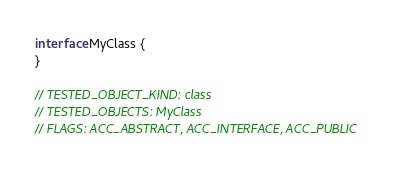Convert code to text. <code><loc_0><loc_0><loc_500><loc_500><_Kotlin_>interface MyClass {
}

// TESTED_OBJECT_KIND: class
// TESTED_OBJECTS: MyClass
// FLAGS: ACC_ABSTRACT, ACC_INTERFACE, ACC_PUBLIC
</code> 